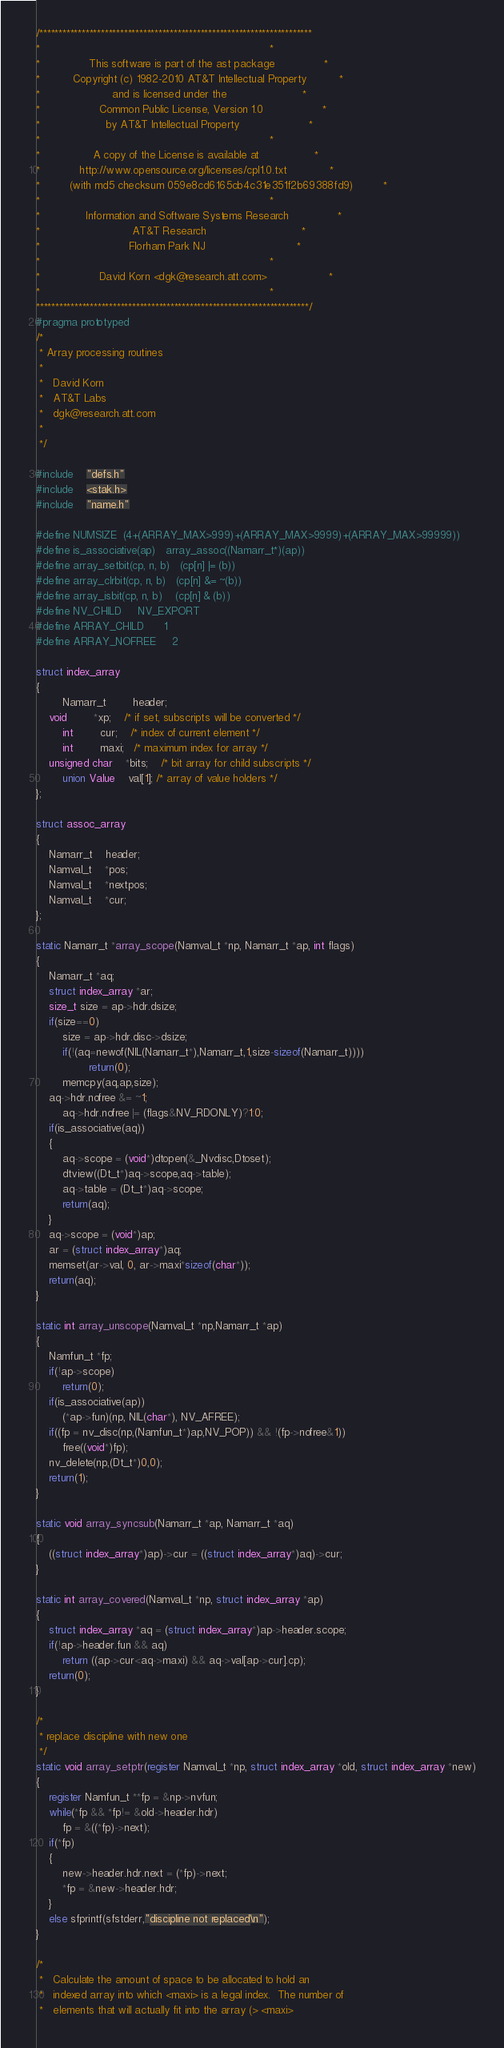<code> <loc_0><loc_0><loc_500><loc_500><_C_>/***********************************************************************
*                                                                      *
*               This software is part of the ast package               *
*          Copyright (c) 1982-2010 AT&T Intellectual Property          *
*                      and is licensed under the                       *
*                  Common Public License, Version 1.0                  *
*                    by AT&T Intellectual Property                     *
*                                                                      *
*                A copy of the License is available at                 *
*            http://www.opensource.org/licenses/cpl1.0.txt             *
*         (with md5 checksum 059e8cd6165cb4c31e351f2b69388fd9)         *
*                                                                      *
*              Information and Software Systems Research               *
*                            AT&T Research                             *
*                           Florham Park NJ                            *
*                                                                      *
*                  David Korn <dgk@research.att.com>                   *
*                                                                      *
***********************************************************************/
#pragma prototyped
/*
 * Array processing routines
 *
 *   David Korn
 *   AT&T Labs
 *   dgk@research.att.com
 *
 */

#include	"defs.h"
#include	<stak.h>
#include	"name.h"

#define NUMSIZE	(4+(ARRAY_MAX>999)+(ARRAY_MAX>9999)+(ARRAY_MAX>99999))
#define is_associative(ap)	array_assoc((Namarr_t*)(ap))
#define array_setbit(cp, n, b)	(cp[n] |= (b))
#define array_clrbit(cp, n, b)	(cp[n] &= ~(b))
#define array_isbit(cp, n, b)	(cp[n] & (b))
#define NV_CHILD		NV_EXPORT
#define ARRAY_CHILD		1
#define ARRAY_NOFREE		2

struct index_array
{
        Namarr_t        header;
	void		*xp;	/* if set, subscripts will be converted */
        int		cur;    /* index of current element */
        int		maxi;   /* maximum index for array */
	unsigned char	*bits;	/* bit array for child subscripts */
        union Value	val[1]; /* array of value holders */
};

struct assoc_array
{
	Namarr_t	header;
	Namval_t	*pos;
	Namval_t	*nextpos;
	Namval_t	*cur;
};

static Namarr_t *array_scope(Namval_t *np, Namarr_t *ap, int flags)
{
	Namarr_t *aq;
	struct index_array *ar;
	size_t size = ap->hdr.dsize;
	if(size==0)
		size = ap->hdr.disc->dsize;
        if(!(aq=newof(NIL(Namarr_t*),Namarr_t,1,size-sizeof(Namarr_t))))
                return(0);
        memcpy(aq,ap,size);
	aq->hdr.nofree &= ~1;
        aq->hdr.nofree |= (flags&NV_RDONLY)?1:0;
	if(is_associative(aq))
	{
		aq->scope = (void*)dtopen(&_Nvdisc,Dtoset);
		dtview((Dt_t*)aq->scope,aq->table);
		aq->table = (Dt_t*)aq->scope;
		return(aq);
	}
	aq->scope = (void*)ap;
	ar = (struct index_array*)aq;
	memset(ar->val, 0, ar->maxi*sizeof(char*));
	return(aq);
}

static int array_unscope(Namval_t *np,Namarr_t *ap)
{
	Namfun_t *fp;
	if(!ap->scope)
		return(0);
	if(is_associative(ap))
		(*ap->fun)(np, NIL(char*), NV_AFREE);
	if((fp = nv_disc(np,(Namfun_t*)ap,NV_POP)) && !(fp->nofree&1))
		free((void*)fp);
	nv_delete(np,(Dt_t*)0,0);
	return(1);
}

static void array_syncsub(Namarr_t *ap, Namarr_t *aq)
{
	((struct index_array*)ap)->cur = ((struct index_array*)aq)->cur;
}

static int array_covered(Namval_t *np, struct index_array *ap)
{
	struct index_array *aq = (struct index_array*)ap->header.scope;
	if(!ap->header.fun && aq)
		return ((ap->cur<aq->maxi) && aq->val[ap->cur].cp);
	return(0);
}

/*
 * replace discipline with new one
 */
static void array_setptr(register Namval_t *np, struct index_array *old, struct index_array *new)
{
	register Namfun_t **fp = &np->nvfun;
	while(*fp && *fp!= &old->header.hdr)
		fp = &((*fp)->next);
	if(*fp)
	{
		new->header.hdr.next = (*fp)->next;
		*fp = &new->header.hdr;
	}
	else sfprintf(sfstderr,"discipline not replaced\n");
}

/*
 *   Calculate the amount of space to be allocated to hold an
 *   indexed array into which <maxi> is a legal index.  The number of
 *   elements that will actually fit into the array (> <maxi></code> 